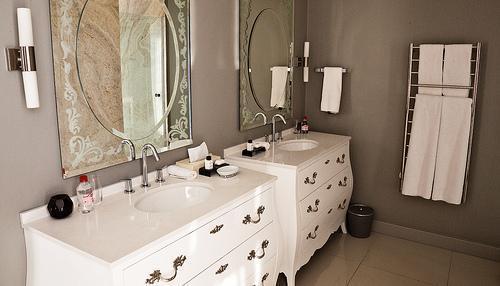How many sinks are there?
Give a very brief answer. 2. 